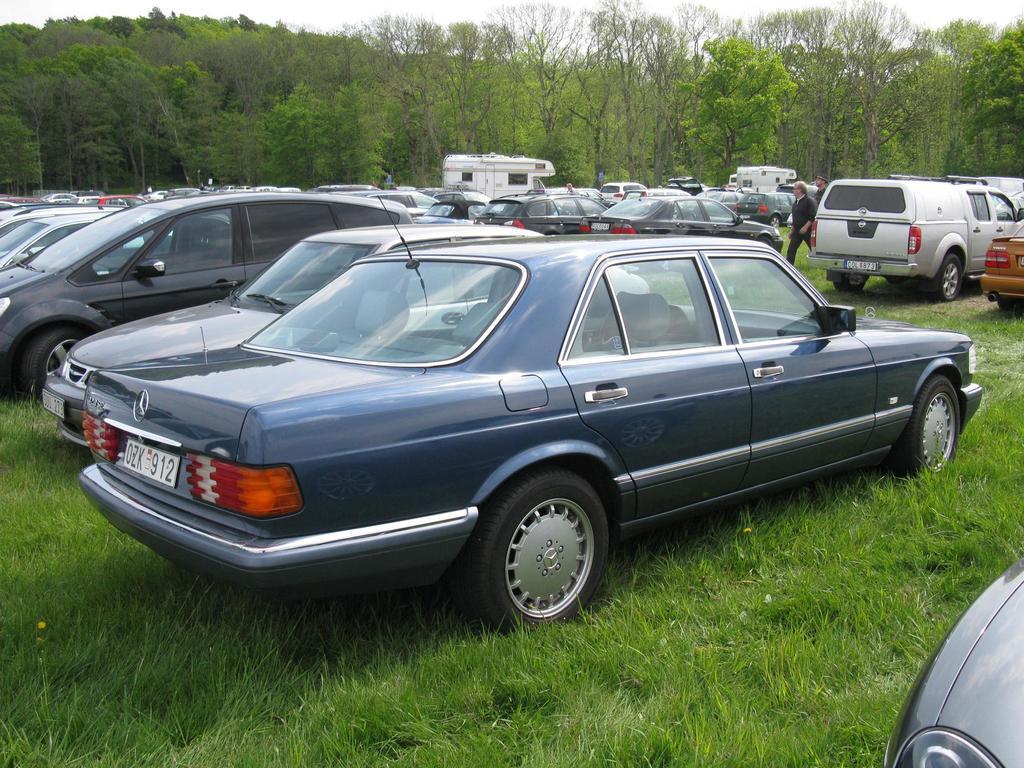What is on the license plate?
Give a very brief answer. Ozk 912. What is the last 3 numbers on the tag?
Provide a short and direct response. 912. 